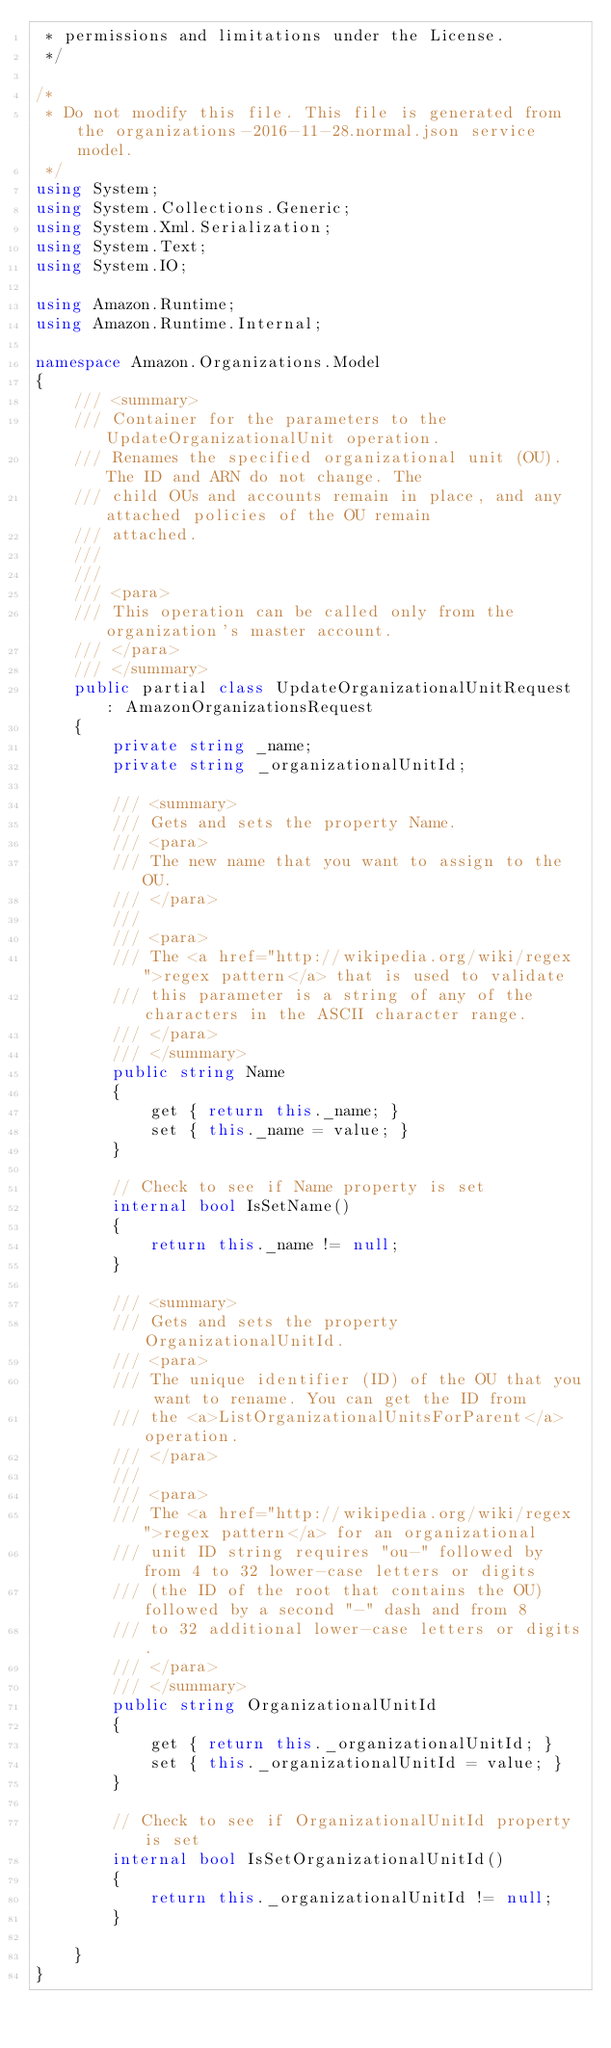Convert code to text. <code><loc_0><loc_0><loc_500><loc_500><_C#_> * permissions and limitations under the License.
 */

/*
 * Do not modify this file. This file is generated from the organizations-2016-11-28.normal.json service model.
 */
using System;
using System.Collections.Generic;
using System.Xml.Serialization;
using System.Text;
using System.IO;

using Amazon.Runtime;
using Amazon.Runtime.Internal;

namespace Amazon.Organizations.Model
{
    /// <summary>
    /// Container for the parameters to the UpdateOrganizationalUnit operation.
    /// Renames the specified organizational unit (OU). The ID and ARN do not change. The
    /// child OUs and accounts remain in place, and any attached policies of the OU remain
    /// attached. 
    /// 
    ///  
    /// <para>
    /// This operation can be called only from the organization's master account.
    /// </para>
    /// </summary>
    public partial class UpdateOrganizationalUnitRequest : AmazonOrganizationsRequest
    {
        private string _name;
        private string _organizationalUnitId;

        /// <summary>
        /// Gets and sets the property Name. 
        /// <para>
        /// The new name that you want to assign to the OU.
        /// </para>
        ///  
        /// <para>
        /// The <a href="http://wikipedia.org/wiki/regex">regex pattern</a> that is used to validate
        /// this parameter is a string of any of the characters in the ASCII character range.
        /// </para>
        /// </summary>
        public string Name
        {
            get { return this._name; }
            set { this._name = value; }
        }

        // Check to see if Name property is set
        internal bool IsSetName()
        {
            return this._name != null;
        }

        /// <summary>
        /// Gets and sets the property OrganizationalUnitId. 
        /// <para>
        /// The unique identifier (ID) of the OU that you want to rename. You can get the ID from
        /// the <a>ListOrganizationalUnitsForParent</a> operation.
        /// </para>
        ///  
        /// <para>
        /// The <a href="http://wikipedia.org/wiki/regex">regex pattern</a> for an organizational
        /// unit ID string requires "ou-" followed by from 4 to 32 lower-case letters or digits
        /// (the ID of the root that contains the OU) followed by a second "-" dash and from 8
        /// to 32 additional lower-case letters or digits.
        /// </para>
        /// </summary>
        public string OrganizationalUnitId
        {
            get { return this._organizationalUnitId; }
            set { this._organizationalUnitId = value; }
        }

        // Check to see if OrganizationalUnitId property is set
        internal bool IsSetOrganizationalUnitId()
        {
            return this._organizationalUnitId != null;
        }

    }
}</code> 